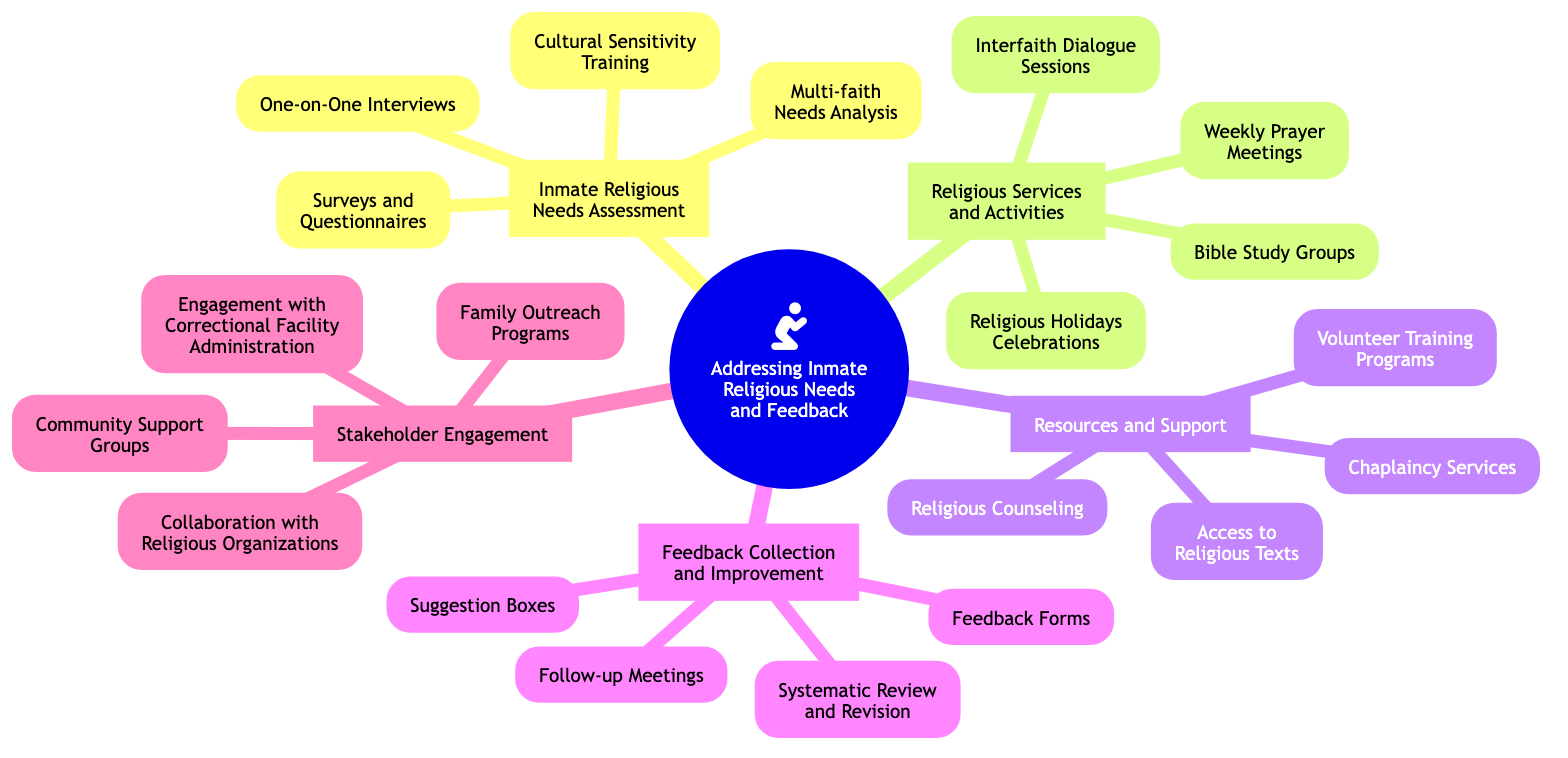What is the primary topic of the diagram? The diagram's core topic is explicitly stated at the root node, which is "Addressing Inmate Religious Needs and Feedback."
Answer: Addressing Inmate Religious Needs and Feedback How many subtopics are there? By counting the distinct branches stemming from the core topic, we can identify that there are five subtopics related to inmate religious needs and feedback.
Answer: 5 Name one element under "Resources and Support." Looking at the "Resources and Support" subtopic, one can see multiple elements listed. An example is "Access to Religious Texts."
Answer: Access to Religious Texts How many elements are listed under "Feedback Collection and Improvement"? By inspecting the elements under this subtopic, it is clear that there are four distinct items provided.
Answer: 4 What is one method of "Inmate Religious Needs Assessment"? Referring to the listed elements beneath the "Inmate Religious Needs Assessment" subtopic, we can select "One-on-One Interviews" as an example method.
Answer: One-on-One Interviews Identify a resource mentioned under "Religious Services and Activities." Under the "Religious Services and Activities" subtopic, one can see various activities. "Bible Study Groups" is one such resource mentioned.
Answer: Bible Study Groups How does "Stakeholder Engagement" relate to "Family Outreach Programs"? "Family Outreach Programs" is an element found within the "Stakeholder Engagement" subtopic, indicating it is a way to involve stakeholders in addressing religious needs.
Answer: Engagement Which two subtopics focus on feedback and improvement? The subtopics that specifically relate to feedback and improvement are "Feedback Collection and Improvement" and "Stakeholder Engagement," as they both emphasize gathering and utilizing feedback.
Answer: Feedback Collection and Improvement, Stakeholder Engagement What is the significance of "Cultural Sensitivity Training"? "Cultural Sensitivity Training" falls under "Inmate Religious Needs Assessment," which emphasizes the importance of understanding diverse cultural backgrounds in fulfilling religious needs within the inmate population.
Answer: Understanding diverse cultural backgrounds 